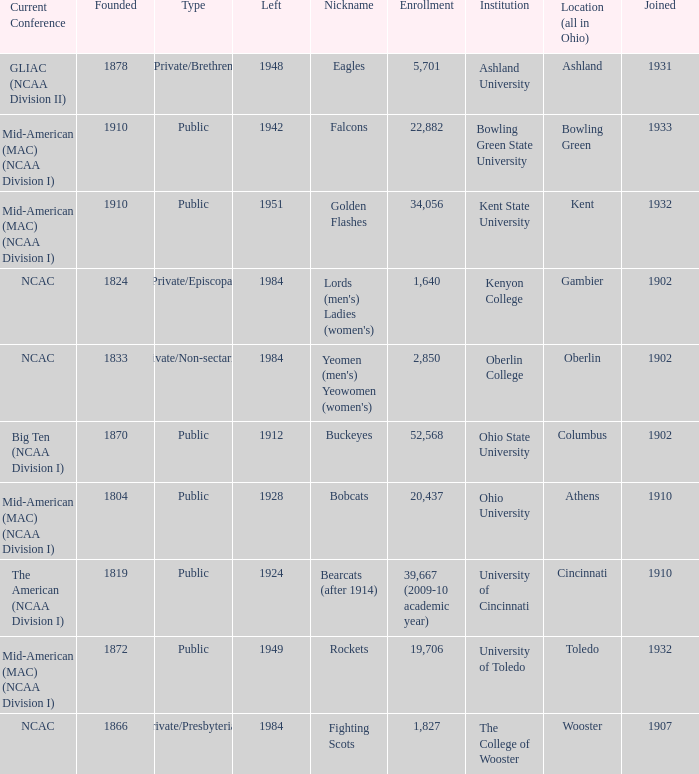Which year did enrolled Gambier members leave? 1984.0. Can you give me this table as a dict? {'header': ['Current Conference', 'Founded', 'Type', 'Left', 'Nickname', 'Enrollment', 'Institution', 'Location (all in Ohio)', 'Joined'], 'rows': [['GLIAC (NCAA Division II)', '1878', 'Private/Brethren', '1948', 'Eagles', '5,701', 'Ashland University', 'Ashland', '1931'], ['Mid-American (MAC) (NCAA Division I)', '1910', 'Public', '1942', 'Falcons', '22,882', 'Bowling Green State University', 'Bowling Green', '1933'], ['Mid-American (MAC) (NCAA Division I)', '1910', 'Public', '1951', 'Golden Flashes', '34,056', 'Kent State University', 'Kent', '1932'], ['NCAC', '1824', 'Private/Episcopal', '1984', "Lords (men's) Ladies (women's)", '1,640', 'Kenyon College', 'Gambier', '1902'], ['NCAC', '1833', 'Private/Non-sectarian', '1984', "Yeomen (men's) Yeowomen (women's)", '2,850', 'Oberlin College', 'Oberlin', '1902'], ['Big Ten (NCAA Division I)', '1870', 'Public', '1912', 'Buckeyes', '52,568', 'Ohio State University', 'Columbus', '1902'], ['Mid-American (MAC) (NCAA Division I)', '1804', 'Public', '1928', 'Bobcats', '20,437', 'Ohio University', 'Athens', '1910'], ['The American (NCAA Division I)', '1819', 'Public', '1924', 'Bearcats (after 1914)', '39,667 (2009-10 academic year)', 'University of Cincinnati', 'Cincinnati', '1910'], ['Mid-American (MAC) (NCAA Division I)', '1872', 'Public', '1949', 'Rockets', '19,706', 'University of Toledo', 'Toledo', '1932'], ['NCAC', '1866', 'Private/Presbyterian', '1984', 'Fighting Scots', '1,827', 'The College of Wooster', 'Wooster', '1907']]} 